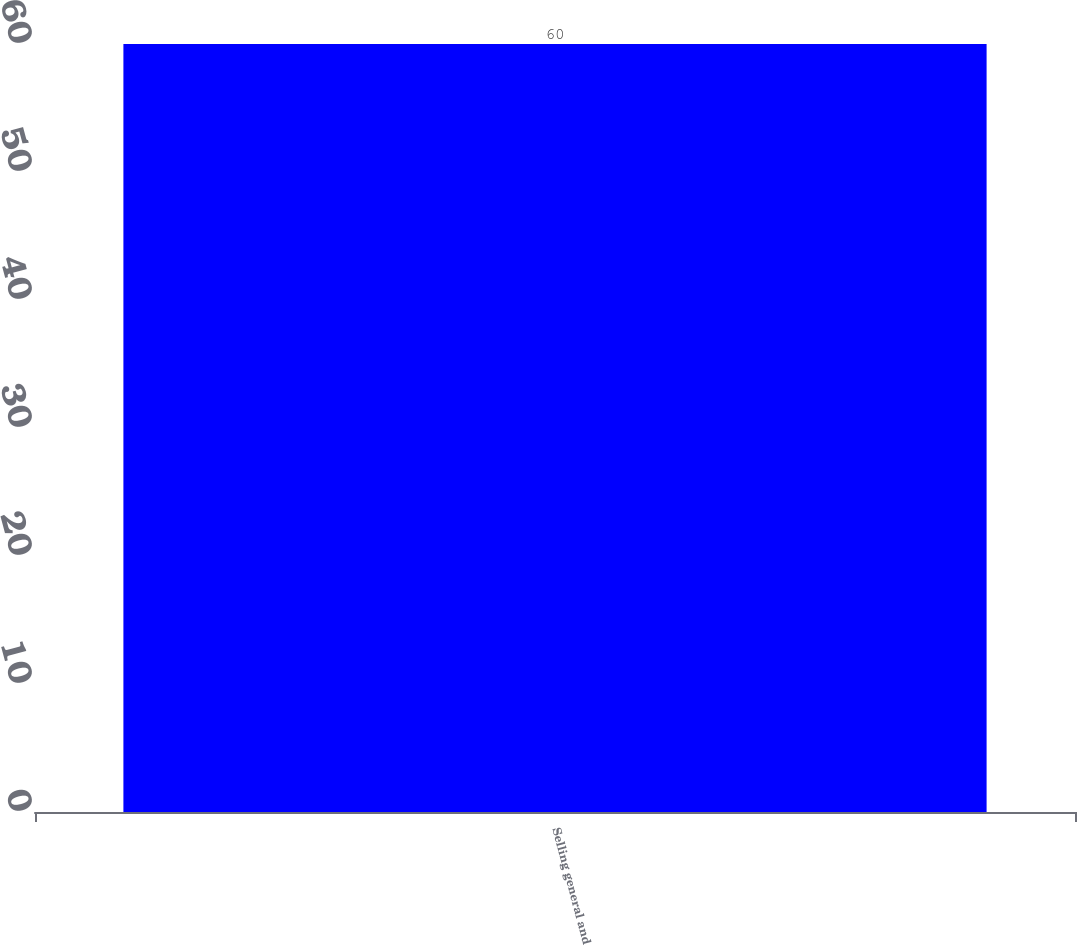Convert chart. <chart><loc_0><loc_0><loc_500><loc_500><bar_chart><fcel>Selling general and<nl><fcel>60<nl></chart> 